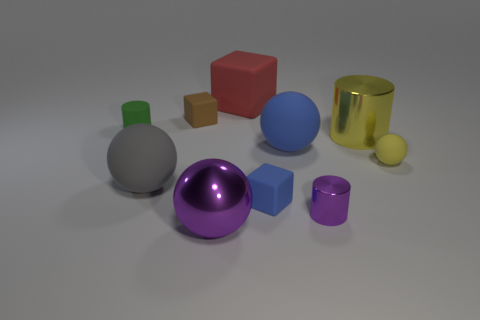Is the number of small rubber spheres behind the large rubber block greater than the number of tiny red matte cylinders?
Provide a succinct answer. No. What size is the cylinder that is the same material as the blue ball?
Offer a terse response. Small. Are there any matte balls of the same color as the big shiny cylinder?
Provide a short and direct response. Yes. How many objects are either large brown matte blocks or small things that are on the left side of the big gray object?
Provide a succinct answer. 1. Are there more big red cubes than big purple blocks?
Your response must be concise. Yes. What is the size of the metal cylinder that is the same color as the tiny rubber ball?
Make the answer very short. Large. Are there any large green blocks made of the same material as the large purple sphere?
Ensure brevity in your answer.  No. What shape is the large object that is both to the left of the large blue object and behind the big blue matte thing?
Keep it short and to the point. Cube. What number of other objects are there of the same shape as the large gray object?
Ensure brevity in your answer.  3. What is the size of the green cylinder?
Give a very brief answer. Small. 